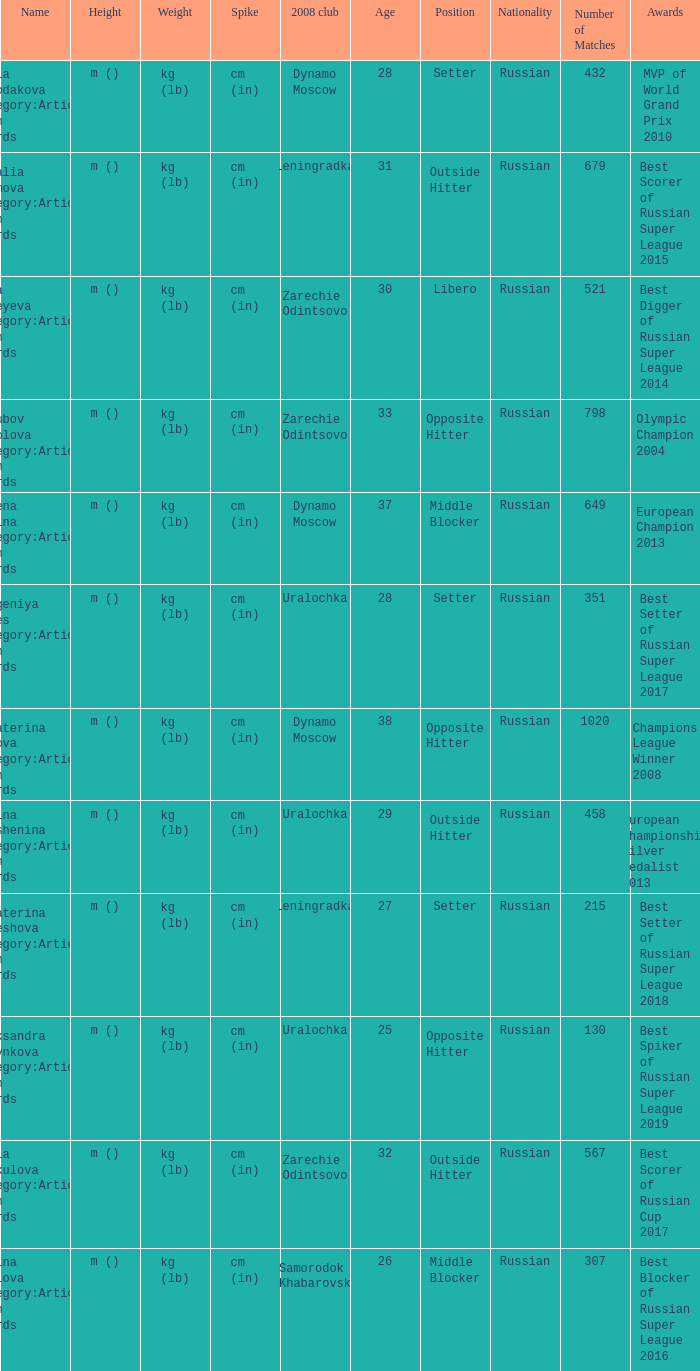What is the name when the 2008 club is zarechie odintsovo? Olga Fateyeva Category:Articles with hCards, Lioubov Sokolova Category:Articles with hCards, Yulia Merkulova Category:Articles with hCards. 